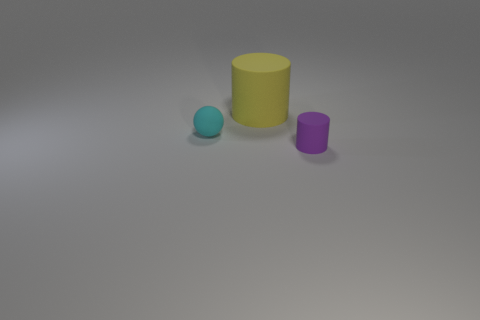There is a purple matte cylinder; does it have the same size as the thing that is on the left side of the big yellow matte cylinder?
Make the answer very short. Yes. There is a rubber object behind the cyan thing; are there any tiny matte objects that are on the left side of it?
Ensure brevity in your answer.  Yes. Are there any yellow objects of the same shape as the small cyan object?
Your answer should be very brief. No. There is a object behind the small thing that is to the left of the purple object; what number of tiny rubber things are to the left of it?
Your answer should be very brief. 1. What number of objects are cylinders behind the tiny cyan ball or things that are behind the tiny cyan sphere?
Your answer should be compact. 1. Is the number of purple matte things in front of the yellow rubber cylinder greater than the number of cyan spheres behind the cyan rubber ball?
Make the answer very short. Yes. Does the tiny cyan object behind the tiny purple matte thing have the same shape as the purple matte thing that is in front of the cyan sphere?
Offer a terse response. No. Are there any yellow rubber objects of the same size as the cyan sphere?
Your response must be concise. No. How many brown objects are rubber cylinders or small rubber things?
Offer a terse response. 0. Is there anything else that is the same shape as the small cyan matte thing?
Make the answer very short. No. 